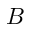Convert formula to latex. <formula><loc_0><loc_0><loc_500><loc_500>B</formula> 